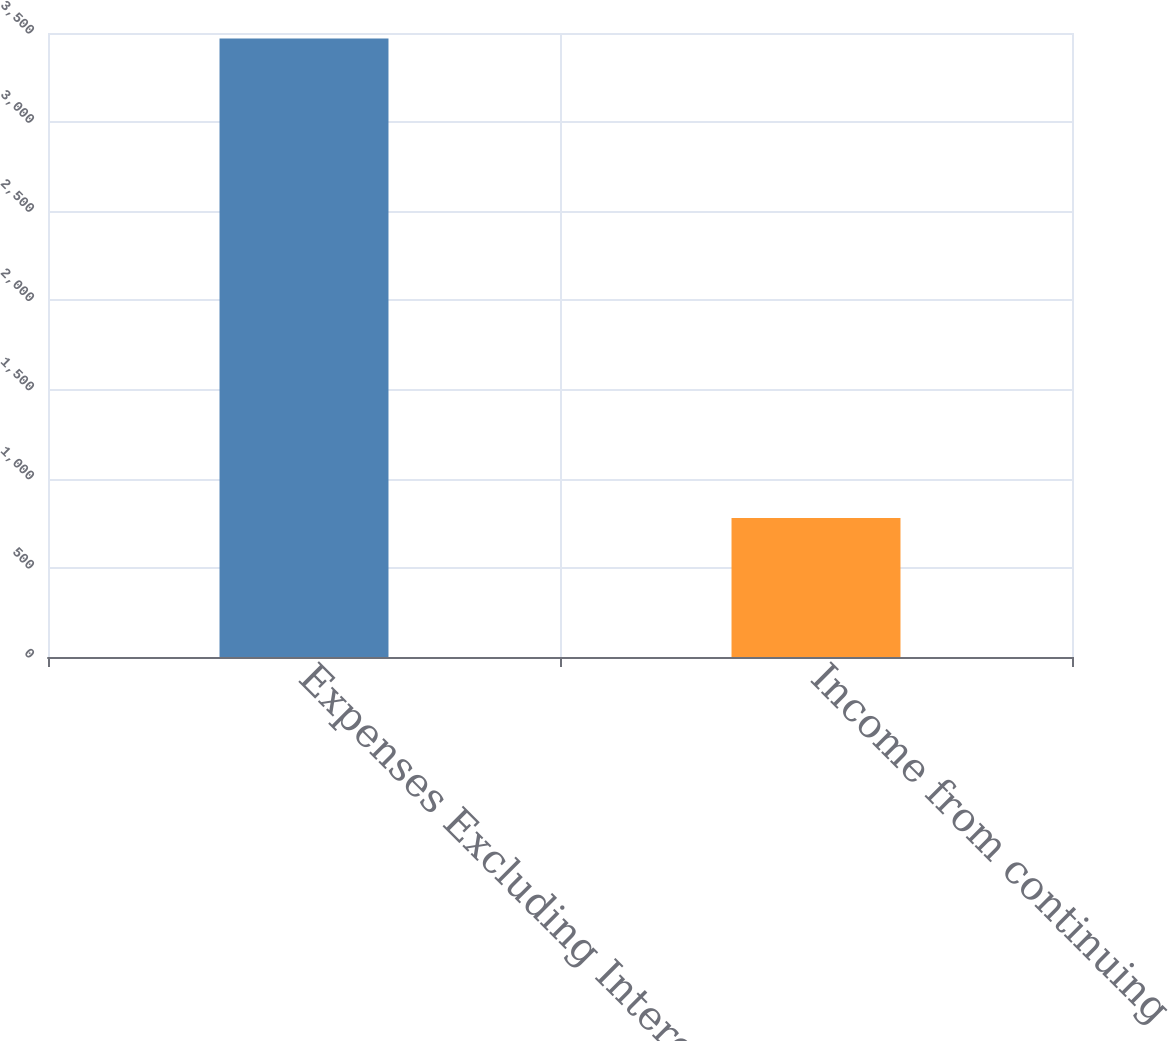<chart> <loc_0><loc_0><loc_500><loc_500><bar_chart><fcel>Expenses Excluding Interest<fcel>Income from continuing<nl><fcel>3469<fcel>779<nl></chart> 